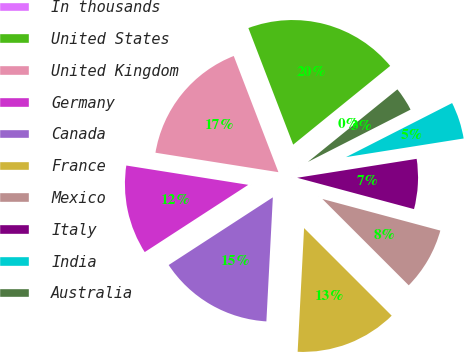Convert chart to OTSL. <chart><loc_0><loc_0><loc_500><loc_500><pie_chart><fcel>In thousands<fcel>United States<fcel>United Kingdom<fcel>Germany<fcel>Canada<fcel>France<fcel>Mexico<fcel>Italy<fcel>India<fcel>Australia<nl><fcel>0.01%<fcel>19.99%<fcel>16.66%<fcel>11.67%<fcel>15.0%<fcel>13.33%<fcel>8.33%<fcel>6.67%<fcel>5.0%<fcel>3.34%<nl></chart> 